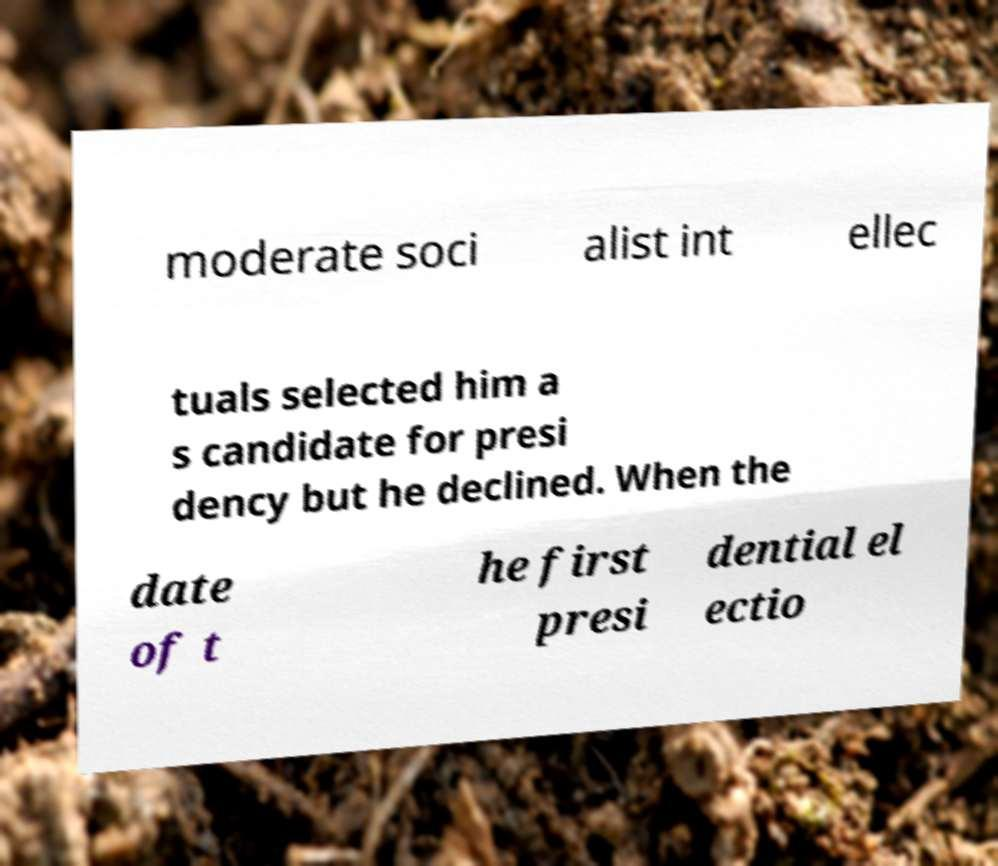Please identify and transcribe the text found in this image. moderate soci alist int ellec tuals selected him a s candidate for presi dency but he declined. When the date of t he first presi dential el ectio 